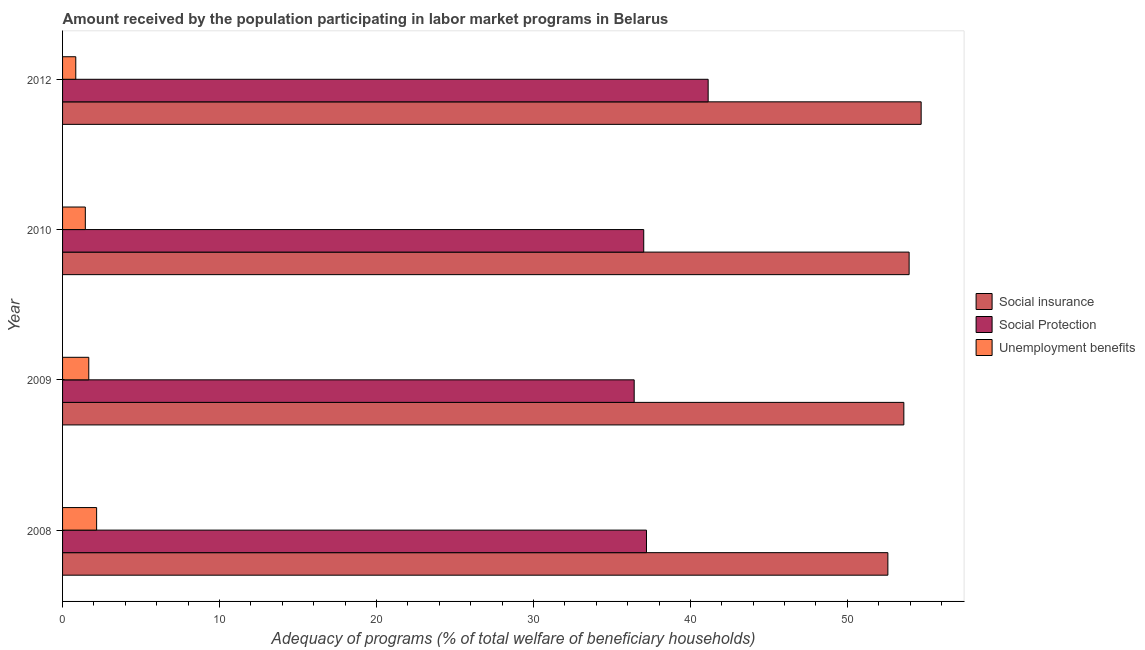How many different coloured bars are there?
Keep it short and to the point. 3. How many groups of bars are there?
Ensure brevity in your answer.  4. Are the number of bars per tick equal to the number of legend labels?
Make the answer very short. Yes. What is the label of the 4th group of bars from the top?
Your answer should be compact. 2008. What is the amount received by the population participating in unemployment benefits programs in 2008?
Your answer should be very brief. 2.17. Across all years, what is the maximum amount received by the population participating in social protection programs?
Make the answer very short. 41.13. Across all years, what is the minimum amount received by the population participating in unemployment benefits programs?
Provide a succinct answer. 0.84. In which year was the amount received by the population participating in unemployment benefits programs maximum?
Provide a succinct answer. 2008. What is the total amount received by the population participating in social insurance programs in the graph?
Offer a very short reply. 214.81. What is the difference between the amount received by the population participating in social insurance programs in 2009 and that in 2010?
Make the answer very short. -0.34. What is the difference between the amount received by the population participating in social protection programs in 2008 and the amount received by the population participating in unemployment benefits programs in 2012?
Ensure brevity in your answer.  36.36. What is the average amount received by the population participating in social protection programs per year?
Keep it short and to the point. 37.94. In the year 2010, what is the difference between the amount received by the population participating in social protection programs and amount received by the population participating in social insurance programs?
Ensure brevity in your answer.  -16.91. In how many years, is the amount received by the population participating in social insurance programs greater than 14 %?
Provide a succinct answer. 4. What is the ratio of the amount received by the population participating in social insurance programs in 2009 to that in 2010?
Make the answer very short. 0.99. Is the difference between the amount received by the population participating in social insurance programs in 2008 and 2010 greater than the difference between the amount received by the population participating in social protection programs in 2008 and 2010?
Make the answer very short. No. What is the difference between the highest and the second highest amount received by the population participating in unemployment benefits programs?
Offer a terse response. 0.5. What is the difference between the highest and the lowest amount received by the population participating in social insurance programs?
Your answer should be compact. 2.12. Is the sum of the amount received by the population participating in social protection programs in 2008 and 2010 greater than the maximum amount received by the population participating in unemployment benefits programs across all years?
Ensure brevity in your answer.  Yes. What does the 3rd bar from the top in 2008 represents?
Give a very brief answer. Social insurance. What does the 2nd bar from the bottom in 2010 represents?
Provide a short and direct response. Social Protection. Are all the bars in the graph horizontal?
Keep it short and to the point. Yes. How many years are there in the graph?
Your response must be concise. 4. What is the difference between two consecutive major ticks on the X-axis?
Your response must be concise. 10. Does the graph contain grids?
Make the answer very short. No. What is the title of the graph?
Ensure brevity in your answer.  Amount received by the population participating in labor market programs in Belarus. Does "Primary education" appear as one of the legend labels in the graph?
Your response must be concise. No. What is the label or title of the X-axis?
Your answer should be compact. Adequacy of programs (% of total welfare of beneficiary households). What is the Adequacy of programs (% of total welfare of beneficiary households) of Social insurance in 2008?
Offer a terse response. 52.58. What is the Adequacy of programs (% of total welfare of beneficiary households) in Social Protection in 2008?
Your answer should be compact. 37.2. What is the Adequacy of programs (% of total welfare of beneficiary households) of Unemployment benefits in 2008?
Keep it short and to the point. 2.17. What is the Adequacy of programs (% of total welfare of beneficiary households) in Social insurance in 2009?
Offer a very short reply. 53.6. What is the Adequacy of programs (% of total welfare of beneficiary households) in Social Protection in 2009?
Provide a short and direct response. 36.42. What is the Adequacy of programs (% of total welfare of beneficiary households) in Unemployment benefits in 2009?
Your answer should be very brief. 1.67. What is the Adequacy of programs (% of total welfare of beneficiary households) in Social insurance in 2010?
Make the answer very short. 53.93. What is the Adequacy of programs (% of total welfare of beneficiary households) of Social Protection in 2010?
Your response must be concise. 37.03. What is the Adequacy of programs (% of total welfare of beneficiary households) in Unemployment benefits in 2010?
Your answer should be compact. 1.45. What is the Adequacy of programs (% of total welfare of beneficiary households) in Social insurance in 2012?
Your answer should be very brief. 54.7. What is the Adequacy of programs (% of total welfare of beneficiary households) in Social Protection in 2012?
Keep it short and to the point. 41.13. What is the Adequacy of programs (% of total welfare of beneficiary households) in Unemployment benefits in 2012?
Offer a terse response. 0.84. Across all years, what is the maximum Adequacy of programs (% of total welfare of beneficiary households) of Social insurance?
Make the answer very short. 54.7. Across all years, what is the maximum Adequacy of programs (% of total welfare of beneficiary households) in Social Protection?
Your answer should be compact. 41.13. Across all years, what is the maximum Adequacy of programs (% of total welfare of beneficiary households) of Unemployment benefits?
Ensure brevity in your answer.  2.17. Across all years, what is the minimum Adequacy of programs (% of total welfare of beneficiary households) of Social insurance?
Provide a succinct answer. 52.58. Across all years, what is the minimum Adequacy of programs (% of total welfare of beneficiary households) in Social Protection?
Provide a short and direct response. 36.42. Across all years, what is the minimum Adequacy of programs (% of total welfare of beneficiary households) in Unemployment benefits?
Your answer should be compact. 0.84. What is the total Adequacy of programs (% of total welfare of beneficiary households) in Social insurance in the graph?
Your response must be concise. 214.81. What is the total Adequacy of programs (% of total welfare of beneficiary households) in Social Protection in the graph?
Offer a terse response. 151.77. What is the total Adequacy of programs (% of total welfare of beneficiary households) of Unemployment benefits in the graph?
Give a very brief answer. 6.13. What is the difference between the Adequacy of programs (% of total welfare of beneficiary households) of Social insurance in 2008 and that in 2009?
Your answer should be compact. -1.02. What is the difference between the Adequacy of programs (% of total welfare of beneficiary households) of Social Protection in 2008 and that in 2009?
Make the answer very short. 0.78. What is the difference between the Adequacy of programs (% of total welfare of beneficiary households) of Unemployment benefits in 2008 and that in 2009?
Your answer should be very brief. 0.5. What is the difference between the Adequacy of programs (% of total welfare of beneficiary households) in Social insurance in 2008 and that in 2010?
Give a very brief answer. -1.35. What is the difference between the Adequacy of programs (% of total welfare of beneficiary households) in Social Protection in 2008 and that in 2010?
Make the answer very short. 0.18. What is the difference between the Adequacy of programs (% of total welfare of beneficiary households) in Unemployment benefits in 2008 and that in 2010?
Make the answer very short. 0.72. What is the difference between the Adequacy of programs (% of total welfare of beneficiary households) in Social insurance in 2008 and that in 2012?
Offer a very short reply. -2.12. What is the difference between the Adequacy of programs (% of total welfare of beneficiary households) in Social Protection in 2008 and that in 2012?
Provide a short and direct response. -3.93. What is the difference between the Adequacy of programs (% of total welfare of beneficiary households) in Unemployment benefits in 2008 and that in 2012?
Make the answer very short. 1.33. What is the difference between the Adequacy of programs (% of total welfare of beneficiary households) of Social insurance in 2009 and that in 2010?
Your answer should be very brief. -0.34. What is the difference between the Adequacy of programs (% of total welfare of beneficiary households) of Social Protection in 2009 and that in 2010?
Provide a short and direct response. -0.61. What is the difference between the Adequacy of programs (% of total welfare of beneficiary households) of Unemployment benefits in 2009 and that in 2010?
Make the answer very short. 0.22. What is the difference between the Adequacy of programs (% of total welfare of beneficiary households) of Social insurance in 2009 and that in 2012?
Your answer should be compact. -1.1. What is the difference between the Adequacy of programs (% of total welfare of beneficiary households) in Social Protection in 2009 and that in 2012?
Your response must be concise. -4.71. What is the difference between the Adequacy of programs (% of total welfare of beneficiary households) of Unemployment benefits in 2009 and that in 2012?
Your answer should be very brief. 0.83. What is the difference between the Adequacy of programs (% of total welfare of beneficiary households) of Social insurance in 2010 and that in 2012?
Make the answer very short. -0.77. What is the difference between the Adequacy of programs (% of total welfare of beneficiary households) in Social Protection in 2010 and that in 2012?
Make the answer very short. -4.1. What is the difference between the Adequacy of programs (% of total welfare of beneficiary households) of Unemployment benefits in 2010 and that in 2012?
Make the answer very short. 0.61. What is the difference between the Adequacy of programs (% of total welfare of beneficiary households) of Social insurance in 2008 and the Adequacy of programs (% of total welfare of beneficiary households) of Social Protection in 2009?
Offer a very short reply. 16.16. What is the difference between the Adequacy of programs (% of total welfare of beneficiary households) in Social insurance in 2008 and the Adequacy of programs (% of total welfare of beneficiary households) in Unemployment benefits in 2009?
Offer a very short reply. 50.91. What is the difference between the Adequacy of programs (% of total welfare of beneficiary households) of Social Protection in 2008 and the Adequacy of programs (% of total welfare of beneficiary households) of Unemployment benefits in 2009?
Your answer should be very brief. 35.53. What is the difference between the Adequacy of programs (% of total welfare of beneficiary households) of Social insurance in 2008 and the Adequacy of programs (% of total welfare of beneficiary households) of Social Protection in 2010?
Your response must be concise. 15.55. What is the difference between the Adequacy of programs (% of total welfare of beneficiary households) of Social insurance in 2008 and the Adequacy of programs (% of total welfare of beneficiary households) of Unemployment benefits in 2010?
Provide a short and direct response. 51.13. What is the difference between the Adequacy of programs (% of total welfare of beneficiary households) of Social Protection in 2008 and the Adequacy of programs (% of total welfare of beneficiary households) of Unemployment benefits in 2010?
Your answer should be compact. 35.75. What is the difference between the Adequacy of programs (% of total welfare of beneficiary households) in Social insurance in 2008 and the Adequacy of programs (% of total welfare of beneficiary households) in Social Protection in 2012?
Offer a very short reply. 11.45. What is the difference between the Adequacy of programs (% of total welfare of beneficiary households) of Social insurance in 2008 and the Adequacy of programs (% of total welfare of beneficiary households) of Unemployment benefits in 2012?
Keep it short and to the point. 51.74. What is the difference between the Adequacy of programs (% of total welfare of beneficiary households) of Social Protection in 2008 and the Adequacy of programs (% of total welfare of beneficiary households) of Unemployment benefits in 2012?
Your response must be concise. 36.36. What is the difference between the Adequacy of programs (% of total welfare of beneficiary households) in Social insurance in 2009 and the Adequacy of programs (% of total welfare of beneficiary households) in Social Protection in 2010?
Make the answer very short. 16.57. What is the difference between the Adequacy of programs (% of total welfare of beneficiary households) of Social insurance in 2009 and the Adequacy of programs (% of total welfare of beneficiary households) of Unemployment benefits in 2010?
Make the answer very short. 52.15. What is the difference between the Adequacy of programs (% of total welfare of beneficiary households) of Social Protection in 2009 and the Adequacy of programs (% of total welfare of beneficiary households) of Unemployment benefits in 2010?
Your response must be concise. 34.97. What is the difference between the Adequacy of programs (% of total welfare of beneficiary households) of Social insurance in 2009 and the Adequacy of programs (% of total welfare of beneficiary households) of Social Protection in 2012?
Provide a succinct answer. 12.47. What is the difference between the Adequacy of programs (% of total welfare of beneficiary households) of Social insurance in 2009 and the Adequacy of programs (% of total welfare of beneficiary households) of Unemployment benefits in 2012?
Offer a very short reply. 52.76. What is the difference between the Adequacy of programs (% of total welfare of beneficiary households) in Social Protection in 2009 and the Adequacy of programs (% of total welfare of beneficiary households) in Unemployment benefits in 2012?
Your answer should be compact. 35.58. What is the difference between the Adequacy of programs (% of total welfare of beneficiary households) of Social insurance in 2010 and the Adequacy of programs (% of total welfare of beneficiary households) of Social Protection in 2012?
Give a very brief answer. 12.8. What is the difference between the Adequacy of programs (% of total welfare of beneficiary households) of Social insurance in 2010 and the Adequacy of programs (% of total welfare of beneficiary households) of Unemployment benefits in 2012?
Make the answer very short. 53.09. What is the difference between the Adequacy of programs (% of total welfare of beneficiary households) of Social Protection in 2010 and the Adequacy of programs (% of total welfare of beneficiary households) of Unemployment benefits in 2012?
Offer a very short reply. 36.18. What is the average Adequacy of programs (% of total welfare of beneficiary households) in Social insurance per year?
Make the answer very short. 53.7. What is the average Adequacy of programs (% of total welfare of beneficiary households) in Social Protection per year?
Offer a very short reply. 37.94. What is the average Adequacy of programs (% of total welfare of beneficiary households) of Unemployment benefits per year?
Offer a very short reply. 1.53. In the year 2008, what is the difference between the Adequacy of programs (% of total welfare of beneficiary households) of Social insurance and Adequacy of programs (% of total welfare of beneficiary households) of Social Protection?
Offer a very short reply. 15.38. In the year 2008, what is the difference between the Adequacy of programs (% of total welfare of beneficiary households) in Social insurance and Adequacy of programs (% of total welfare of beneficiary households) in Unemployment benefits?
Provide a succinct answer. 50.41. In the year 2008, what is the difference between the Adequacy of programs (% of total welfare of beneficiary households) of Social Protection and Adequacy of programs (% of total welfare of beneficiary households) of Unemployment benefits?
Your answer should be compact. 35.03. In the year 2009, what is the difference between the Adequacy of programs (% of total welfare of beneficiary households) in Social insurance and Adequacy of programs (% of total welfare of beneficiary households) in Social Protection?
Offer a very short reply. 17.18. In the year 2009, what is the difference between the Adequacy of programs (% of total welfare of beneficiary households) of Social insurance and Adequacy of programs (% of total welfare of beneficiary households) of Unemployment benefits?
Give a very brief answer. 51.93. In the year 2009, what is the difference between the Adequacy of programs (% of total welfare of beneficiary households) of Social Protection and Adequacy of programs (% of total welfare of beneficiary households) of Unemployment benefits?
Provide a short and direct response. 34.75. In the year 2010, what is the difference between the Adequacy of programs (% of total welfare of beneficiary households) of Social insurance and Adequacy of programs (% of total welfare of beneficiary households) of Social Protection?
Your answer should be compact. 16.91. In the year 2010, what is the difference between the Adequacy of programs (% of total welfare of beneficiary households) of Social insurance and Adequacy of programs (% of total welfare of beneficiary households) of Unemployment benefits?
Ensure brevity in your answer.  52.48. In the year 2010, what is the difference between the Adequacy of programs (% of total welfare of beneficiary households) in Social Protection and Adequacy of programs (% of total welfare of beneficiary households) in Unemployment benefits?
Your response must be concise. 35.58. In the year 2012, what is the difference between the Adequacy of programs (% of total welfare of beneficiary households) of Social insurance and Adequacy of programs (% of total welfare of beneficiary households) of Social Protection?
Your answer should be compact. 13.57. In the year 2012, what is the difference between the Adequacy of programs (% of total welfare of beneficiary households) in Social insurance and Adequacy of programs (% of total welfare of beneficiary households) in Unemployment benefits?
Your answer should be compact. 53.86. In the year 2012, what is the difference between the Adequacy of programs (% of total welfare of beneficiary households) of Social Protection and Adequacy of programs (% of total welfare of beneficiary households) of Unemployment benefits?
Offer a terse response. 40.29. What is the ratio of the Adequacy of programs (% of total welfare of beneficiary households) in Social insurance in 2008 to that in 2009?
Make the answer very short. 0.98. What is the ratio of the Adequacy of programs (% of total welfare of beneficiary households) in Social Protection in 2008 to that in 2009?
Offer a very short reply. 1.02. What is the ratio of the Adequacy of programs (% of total welfare of beneficiary households) in Unemployment benefits in 2008 to that in 2009?
Make the answer very short. 1.3. What is the ratio of the Adequacy of programs (% of total welfare of beneficiary households) of Social insurance in 2008 to that in 2010?
Provide a succinct answer. 0.97. What is the ratio of the Adequacy of programs (% of total welfare of beneficiary households) of Unemployment benefits in 2008 to that in 2010?
Provide a succinct answer. 1.5. What is the ratio of the Adequacy of programs (% of total welfare of beneficiary households) in Social insurance in 2008 to that in 2012?
Offer a terse response. 0.96. What is the ratio of the Adequacy of programs (% of total welfare of beneficiary households) of Social Protection in 2008 to that in 2012?
Your answer should be compact. 0.9. What is the ratio of the Adequacy of programs (% of total welfare of beneficiary households) in Unemployment benefits in 2008 to that in 2012?
Offer a terse response. 2.58. What is the ratio of the Adequacy of programs (% of total welfare of beneficiary households) in Social insurance in 2009 to that in 2010?
Make the answer very short. 0.99. What is the ratio of the Adequacy of programs (% of total welfare of beneficiary households) of Social Protection in 2009 to that in 2010?
Your answer should be compact. 0.98. What is the ratio of the Adequacy of programs (% of total welfare of beneficiary households) of Unemployment benefits in 2009 to that in 2010?
Provide a short and direct response. 1.15. What is the ratio of the Adequacy of programs (% of total welfare of beneficiary households) of Social insurance in 2009 to that in 2012?
Keep it short and to the point. 0.98. What is the ratio of the Adequacy of programs (% of total welfare of beneficiary households) in Social Protection in 2009 to that in 2012?
Your answer should be compact. 0.89. What is the ratio of the Adequacy of programs (% of total welfare of beneficiary households) in Unemployment benefits in 2009 to that in 2012?
Give a very brief answer. 1.98. What is the ratio of the Adequacy of programs (% of total welfare of beneficiary households) of Social Protection in 2010 to that in 2012?
Provide a succinct answer. 0.9. What is the ratio of the Adequacy of programs (% of total welfare of beneficiary households) of Unemployment benefits in 2010 to that in 2012?
Offer a very short reply. 1.72. What is the difference between the highest and the second highest Adequacy of programs (% of total welfare of beneficiary households) in Social insurance?
Give a very brief answer. 0.77. What is the difference between the highest and the second highest Adequacy of programs (% of total welfare of beneficiary households) of Social Protection?
Offer a terse response. 3.93. What is the difference between the highest and the second highest Adequacy of programs (% of total welfare of beneficiary households) in Unemployment benefits?
Your answer should be very brief. 0.5. What is the difference between the highest and the lowest Adequacy of programs (% of total welfare of beneficiary households) in Social insurance?
Provide a short and direct response. 2.12. What is the difference between the highest and the lowest Adequacy of programs (% of total welfare of beneficiary households) in Social Protection?
Offer a terse response. 4.71. What is the difference between the highest and the lowest Adequacy of programs (% of total welfare of beneficiary households) of Unemployment benefits?
Give a very brief answer. 1.33. 